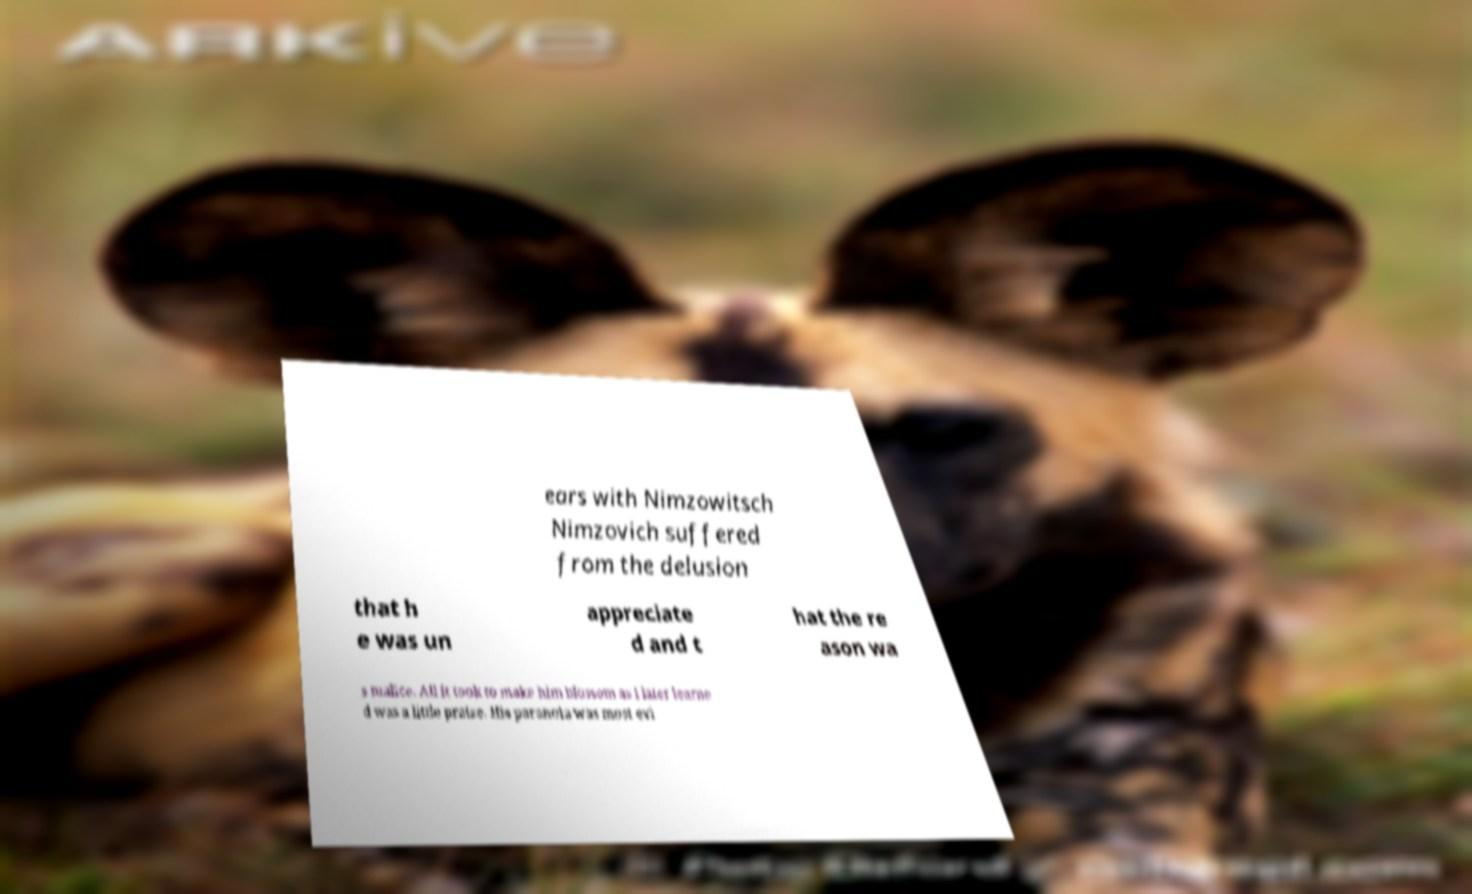For documentation purposes, I need the text within this image transcribed. Could you provide that? ears with Nimzowitsch Nimzovich suffered from the delusion that h e was un appreciate d and t hat the re ason wa s malice. All it took to make him blossom as I later learne d was a little praise. His paranoia was most evi 